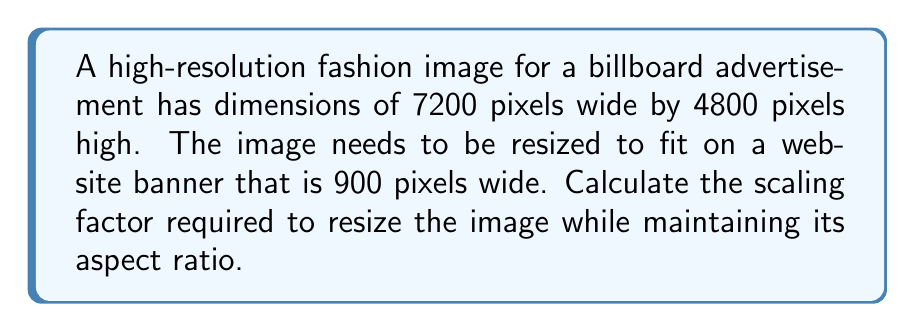Solve this math problem. To resize an image while maintaining its aspect ratio, we need to calculate the scaling factor based on the ratio of the new width to the original width. Here's how to solve this step-by-step:

1. Identify the original dimensions:
   Original width = 7200 pixels
   Original height = 4800 pixels

2. Identify the target width:
   New width = 900 pixels

3. Calculate the scaling factor:
   Scaling factor = New width / Original width
   $$\text{Scaling factor} = \frac{\text{New width}}{\text{Original width}}$$
   $$\text{Scaling factor} = \frac{900}{7200}$$

4. Simplify the fraction:
   $$\text{Scaling factor} = \frac{1}{8} = 0.125$$

5. Verify the result:
   New height = Original height × Scaling factor
   $$\text{New height} = 4800 \times 0.125 = 600 \text{ pixels}$$

This scaling factor will resize the image proportionally, maintaining the aspect ratio. The new dimensions will be 900 pixels wide by 600 pixels high.
Answer: $0.125$ 